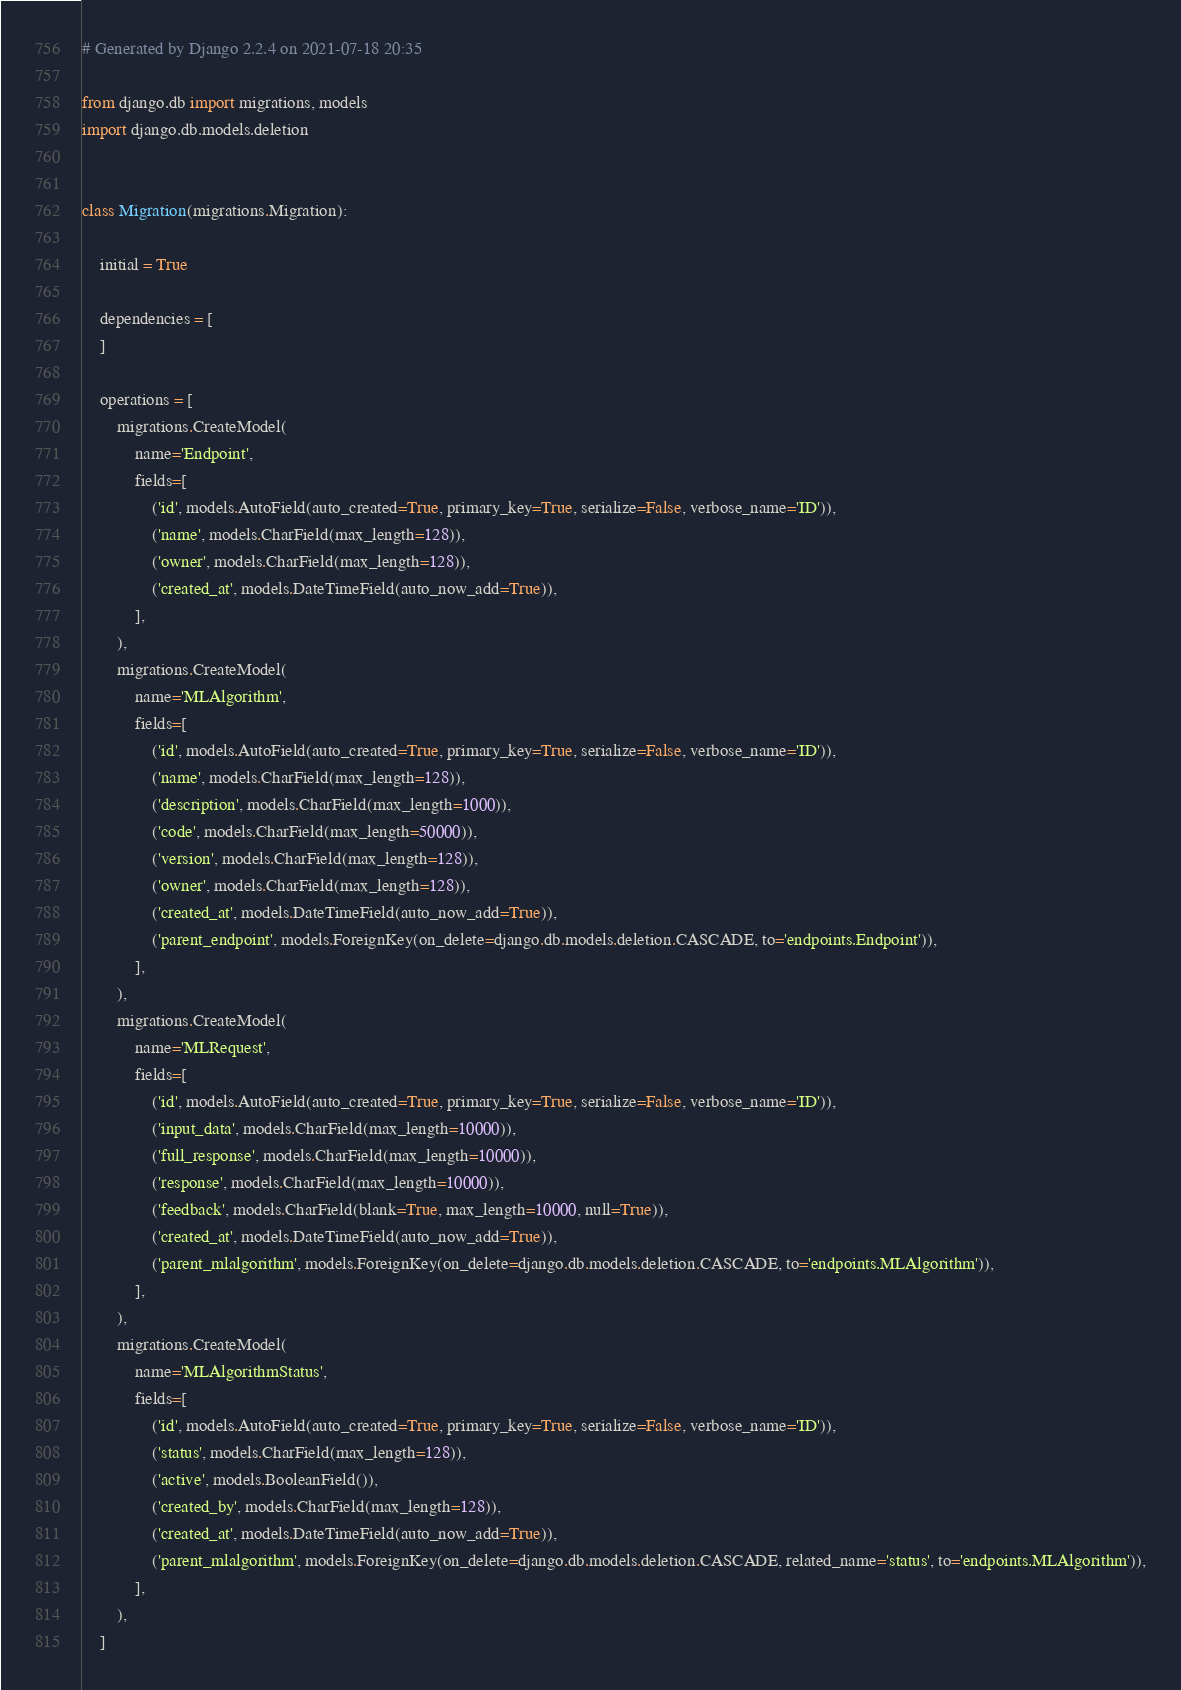Convert code to text. <code><loc_0><loc_0><loc_500><loc_500><_Python_># Generated by Django 2.2.4 on 2021-07-18 20:35

from django.db import migrations, models
import django.db.models.deletion


class Migration(migrations.Migration):

    initial = True

    dependencies = [
    ]

    operations = [
        migrations.CreateModel(
            name='Endpoint',
            fields=[
                ('id', models.AutoField(auto_created=True, primary_key=True, serialize=False, verbose_name='ID')),
                ('name', models.CharField(max_length=128)),
                ('owner', models.CharField(max_length=128)),
                ('created_at', models.DateTimeField(auto_now_add=True)),
            ],
        ),
        migrations.CreateModel(
            name='MLAlgorithm',
            fields=[
                ('id', models.AutoField(auto_created=True, primary_key=True, serialize=False, verbose_name='ID')),
                ('name', models.CharField(max_length=128)),
                ('description', models.CharField(max_length=1000)),
                ('code', models.CharField(max_length=50000)),
                ('version', models.CharField(max_length=128)),
                ('owner', models.CharField(max_length=128)),
                ('created_at', models.DateTimeField(auto_now_add=True)),
                ('parent_endpoint', models.ForeignKey(on_delete=django.db.models.deletion.CASCADE, to='endpoints.Endpoint')),
            ],
        ),
        migrations.CreateModel(
            name='MLRequest',
            fields=[
                ('id', models.AutoField(auto_created=True, primary_key=True, serialize=False, verbose_name='ID')),
                ('input_data', models.CharField(max_length=10000)),
                ('full_response', models.CharField(max_length=10000)),
                ('response', models.CharField(max_length=10000)),
                ('feedback', models.CharField(blank=True, max_length=10000, null=True)),
                ('created_at', models.DateTimeField(auto_now_add=True)),
                ('parent_mlalgorithm', models.ForeignKey(on_delete=django.db.models.deletion.CASCADE, to='endpoints.MLAlgorithm')),
            ],
        ),
        migrations.CreateModel(
            name='MLAlgorithmStatus',
            fields=[
                ('id', models.AutoField(auto_created=True, primary_key=True, serialize=False, verbose_name='ID')),
                ('status', models.CharField(max_length=128)),
                ('active', models.BooleanField()),
                ('created_by', models.CharField(max_length=128)),
                ('created_at', models.DateTimeField(auto_now_add=True)),
                ('parent_mlalgorithm', models.ForeignKey(on_delete=django.db.models.deletion.CASCADE, related_name='status', to='endpoints.MLAlgorithm')),
            ],
        ),
    ]
</code> 